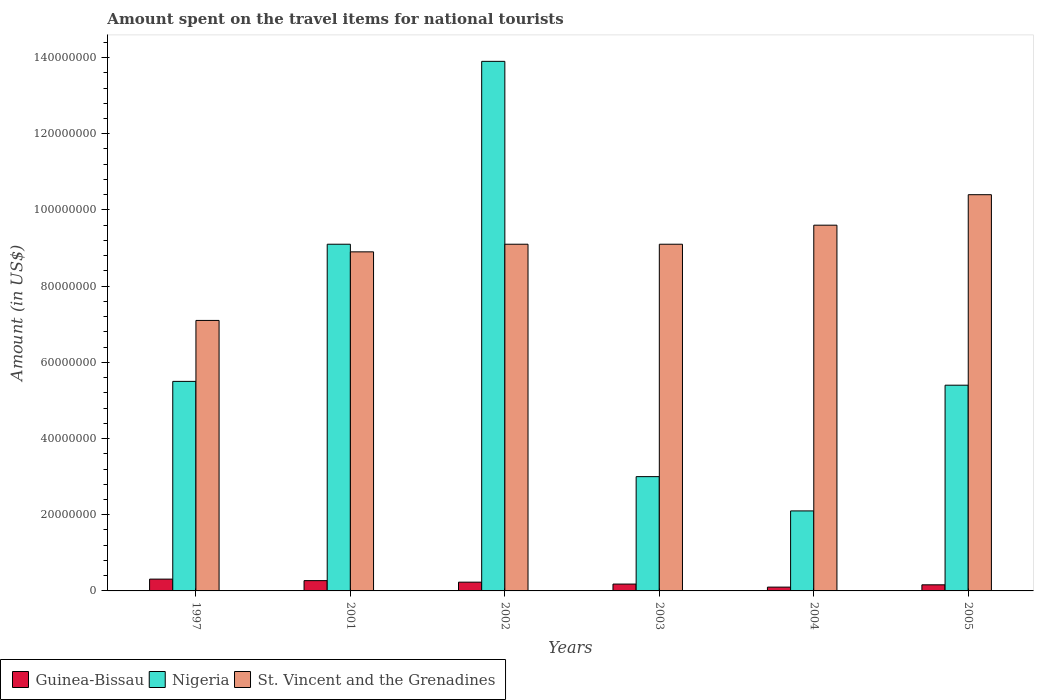How many groups of bars are there?
Provide a short and direct response. 6. Are the number of bars on each tick of the X-axis equal?
Your answer should be very brief. Yes. In how many cases, is the number of bars for a given year not equal to the number of legend labels?
Give a very brief answer. 0. What is the amount spent on the travel items for national tourists in St. Vincent and the Grenadines in 1997?
Provide a succinct answer. 7.10e+07. Across all years, what is the maximum amount spent on the travel items for national tourists in St. Vincent and the Grenadines?
Make the answer very short. 1.04e+08. Across all years, what is the minimum amount spent on the travel items for national tourists in St. Vincent and the Grenadines?
Give a very brief answer. 7.10e+07. In which year was the amount spent on the travel items for national tourists in Guinea-Bissau minimum?
Your answer should be compact. 2004. What is the total amount spent on the travel items for national tourists in Guinea-Bissau in the graph?
Give a very brief answer. 1.25e+07. What is the difference between the amount spent on the travel items for national tourists in Guinea-Bissau in 1997 and that in 2003?
Offer a terse response. 1.30e+06. What is the difference between the amount spent on the travel items for national tourists in Guinea-Bissau in 2003 and the amount spent on the travel items for national tourists in St. Vincent and the Grenadines in 2001?
Ensure brevity in your answer.  -8.72e+07. What is the average amount spent on the travel items for national tourists in Guinea-Bissau per year?
Keep it short and to the point. 2.08e+06. In the year 2005, what is the difference between the amount spent on the travel items for national tourists in St. Vincent and the Grenadines and amount spent on the travel items for national tourists in Guinea-Bissau?
Your answer should be compact. 1.02e+08. What is the ratio of the amount spent on the travel items for national tourists in Nigeria in 1997 to that in 2002?
Keep it short and to the point. 0.4. What is the difference between the highest and the second highest amount spent on the travel items for national tourists in Guinea-Bissau?
Make the answer very short. 4.00e+05. What is the difference between the highest and the lowest amount spent on the travel items for national tourists in St. Vincent and the Grenadines?
Provide a succinct answer. 3.30e+07. What does the 3rd bar from the left in 2001 represents?
Make the answer very short. St. Vincent and the Grenadines. What does the 3rd bar from the right in 2002 represents?
Make the answer very short. Guinea-Bissau. How many years are there in the graph?
Keep it short and to the point. 6. What is the difference between two consecutive major ticks on the Y-axis?
Your response must be concise. 2.00e+07. Does the graph contain any zero values?
Ensure brevity in your answer.  No. Where does the legend appear in the graph?
Give a very brief answer. Bottom left. How are the legend labels stacked?
Keep it short and to the point. Horizontal. What is the title of the graph?
Your answer should be very brief. Amount spent on the travel items for national tourists. What is the Amount (in US$) of Guinea-Bissau in 1997?
Your answer should be compact. 3.10e+06. What is the Amount (in US$) of Nigeria in 1997?
Make the answer very short. 5.50e+07. What is the Amount (in US$) of St. Vincent and the Grenadines in 1997?
Offer a terse response. 7.10e+07. What is the Amount (in US$) of Guinea-Bissau in 2001?
Provide a succinct answer. 2.70e+06. What is the Amount (in US$) in Nigeria in 2001?
Ensure brevity in your answer.  9.10e+07. What is the Amount (in US$) in St. Vincent and the Grenadines in 2001?
Your answer should be compact. 8.90e+07. What is the Amount (in US$) in Guinea-Bissau in 2002?
Offer a very short reply. 2.30e+06. What is the Amount (in US$) in Nigeria in 2002?
Give a very brief answer. 1.39e+08. What is the Amount (in US$) of St. Vincent and the Grenadines in 2002?
Ensure brevity in your answer.  9.10e+07. What is the Amount (in US$) of Guinea-Bissau in 2003?
Offer a very short reply. 1.80e+06. What is the Amount (in US$) of Nigeria in 2003?
Offer a very short reply. 3.00e+07. What is the Amount (in US$) in St. Vincent and the Grenadines in 2003?
Provide a short and direct response. 9.10e+07. What is the Amount (in US$) in Guinea-Bissau in 2004?
Your response must be concise. 1.00e+06. What is the Amount (in US$) of Nigeria in 2004?
Your answer should be very brief. 2.10e+07. What is the Amount (in US$) in St. Vincent and the Grenadines in 2004?
Keep it short and to the point. 9.60e+07. What is the Amount (in US$) of Guinea-Bissau in 2005?
Ensure brevity in your answer.  1.60e+06. What is the Amount (in US$) in Nigeria in 2005?
Make the answer very short. 5.40e+07. What is the Amount (in US$) in St. Vincent and the Grenadines in 2005?
Offer a terse response. 1.04e+08. Across all years, what is the maximum Amount (in US$) of Guinea-Bissau?
Keep it short and to the point. 3.10e+06. Across all years, what is the maximum Amount (in US$) in Nigeria?
Offer a terse response. 1.39e+08. Across all years, what is the maximum Amount (in US$) of St. Vincent and the Grenadines?
Offer a terse response. 1.04e+08. Across all years, what is the minimum Amount (in US$) in Nigeria?
Your response must be concise. 2.10e+07. Across all years, what is the minimum Amount (in US$) in St. Vincent and the Grenadines?
Make the answer very short. 7.10e+07. What is the total Amount (in US$) of Guinea-Bissau in the graph?
Your response must be concise. 1.25e+07. What is the total Amount (in US$) of Nigeria in the graph?
Your answer should be very brief. 3.90e+08. What is the total Amount (in US$) in St. Vincent and the Grenadines in the graph?
Give a very brief answer. 5.42e+08. What is the difference between the Amount (in US$) of Nigeria in 1997 and that in 2001?
Your answer should be very brief. -3.60e+07. What is the difference between the Amount (in US$) of St. Vincent and the Grenadines in 1997 and that in 2001?
Give a very brief answer. -1.80e+07. What is the difference between the Amount (in US$) of Nigeria in 1997 and that in 2002?
Provide a short and direct response. -8.40e+07. What is the difference between the Amount (in US$) in St. Vincent and the Grenadines in 1997 and that in 2002?
Your answer should be compact. -2.00e+07. What is the difference between the Amount (in US$) in Guinea-Bissau in 1997 and that in 2003?
Provide a succinct answer. 1.30e+06. What is the difference between the Amount (in US$) in Nigeria in 1997 and that in 2003?
Give a very brief answer. 2.50e+07. What is the difference between the Amount (in US$) of St. Vincent and the Grenadines in 1997 and that in 2003?
Your answer should be compact. -2.00e+07. What is the difference between the Amount (in US$) in Guinea-Bissau in 1997 and that in 2004?
Your answer should be very brief. 2.10e+06. What is the difference between the Amount (in US$) in Nigeria in 1997 and that in 2004?
Offer a very short reply. 3.40e+07. What is the difference between the Amount (in US$) of St. Vincent and the Grenadines in 1997 and that in 2004?
Offer a terse response. -2.50e+07. What is the difference between the Amount (in US$) in Guinea-Bissau in 1997 and that in 2005?
Offer a terse response. 1.50e+06. What is the difference between the Amount (in US$) of Nigeria in 1997 and that in 2005?
Your response must be concise. 1.00e+06. What is the difference between the Amount (in US$) of St. Vincent and the Grenadines in 1997 and that in 2005?
Your response must be concise. -3.30e+07. What is the difference between the Amount (in US$) in Nigeria in 2001 and that in 2002?
Make the answer very short. -4.80e+07. What is the difference between the Amount (in US$) in St. Vincent and the Grenadines in 2001 and that in 2002?
Your answer should be very brief. -2.00e+06. What is the difference between the Amount (in US$) of Guinea-Bissau in 2001 and that in 2003?
Your answer should be very brief. 9.00e+05. What is the difference between the Amount (in US$) of Nigeria in 2001 and that in 2003?
Your answer should be compact. 6.10e+07. What is the difference between the Amount (in US$) in St. Vincent and the Grenadines in 2001 and that in 2003?
Give a very brief answer. -2.00e+06. What is the difference between the Amount (in US$) of Guinea-Bissau in 2001 and that in 2004?
Give a very brief answer. 1.70e+06. What is the difference between the Amount (in US$) of Nigeria in 2001 and that in 2004?
Your answer should be compact. 7.00e+07. What is the difference between the Amount (in US$) in St. Vincent and the Grenadines in 2001 and that in 2004?
Your answer should be very brief. -7.00e+06. What is the difference between the Amount (in US$) in Guinea-Bissau in 2001 and that in 2005?
Your response must be concise. 1.10e+06. What is the difference between the Amount (in US$) of Nigeria in 2001 and that in 2005?
Provide a succinct answer. 3.70e+07. What is the difference between the Amount (in US$) in St. Vincent and the Grenadines in 2001 and that in 2005?
Your answer should be very brief. -1.50e+07. What is the difference between the Amount (in US$) of Nigeria in 2002 and that in 2003?
Keep it short and to the point. 1.09e+08. What is the difference between the Amount (in US$) in St. Vincent and the Grenadines in 2002 and that in 2003?
Ensure brevity in your answer.  0. What is the difference between the Amount (in US$) of Guinea-Bissau in 2002 and that in 2004?
Give a very brief answer. 1.30e+06. What is the difference between the Amount (in US$) of Nigeria in 2002 and that in 2004?
Your response must be concise. 1.18e+08. What is the difference between the Amount (in US$) in St. Vincent and the Grenadines in 2002 and that in 2004?
Give a very brief answer. -5.00e+06. What is the difference between the Amount (in US$) in Nigeria in 2002 and that in 2005?
Your response must be concise. 8.50e+07. What is the difference between the Amount (in US$) in St. Vincent and the Grenadines in 2002 and that in 2005?
Offer a terse response. -1.30e+07. What is the difference between the Amount (in US$) in Nigeria in 2003 and that in 2004?
Make the answer very short. 9.00e+06. What is the difference between the Amount (in US$) in St. Vincent and the Grenadines in 2003 and that in 2004?
Provide a succinct answer. -5.00e+06. What is the difference between the Amount (in US$) in Guinea-Bissau in 2003 and that in 2005?
Make the answer very short. 2.00e+05. What is the difference between the Amount (in US$) in Nigeria in 2003 and that in 2005?
Keep it short and to the point. -2.40e+07. What is the difference between the Amount (in US$) in St. Vincent and the Grenadines in 2003 and that in 2005?
Provide a short and direct response. -1.30e+07. What is the difference between the Amount (in US$) of Guinea-Bissau in 2004 and that in 2005?
Your answer should be compact. -6.00e+05. What is the difference between the Amount (in US$) of Nigeria in 2004 and that in 2005?
Your answer should be very brief. -3.30e+07. What is the difference between the Amount (in US$) of St. Vincent and the Grenadines in 2004 and that in 2005?
Your answer should be very brief. -8.00e+06. What is the difference between the Amount (in US$) of Guinea-Bissau in 1997 and the Amount (in US$) of Nigeria in 2001?
Give a very brief answer. -8.79e+07. What is the difference between the Amount (in US$) of Guinea-Bissau in 1997 and the Amount (in US$) of St. Vincent and the Grenadines in 2001?
Your answer should be compact. -8.59e+07. What is the difference between the Amount (in US$) of Nigeria in 1997 and the Amount (in US$) of St. Vincent and the Grenadines in 2001?
Your response must be concise. -3.40e+07. What is the difference between the Amount (in US$) in Guinea-Bissau in 1997 and the Amount (in US$) in Nigeria in 2002?
Make the answer very short. -1.36e+08. What is the difference between the Amount (in US$) in Guinea-Bissau in 1997 and the Amount (in US$) in St. Vincent and the Grenadines in 2002?
Your answer should be compact. -8.79e+07. What is the difference between the Amount (in US$) of Nigeria in 1997 and the Amount (in US$) of St. Vincent and the Grenadines in 2002?
Provide a succinct answer. -3.60e+07. What is the difference between the Amount (in US$) of Guinea-Bissau in 1997 and the Amount (in US$) of Nigeria in 2003?
Give a very brief answer. -2.69e+07. What is the difference between the Amount (in US$) in Guinea-Bissau in 1997 and the Amount (in US$) in St. Vincent and the Grenadines in 2003?
Your response must be concise. -8.79e+07. What is the difference between the Amount (in US$) in Nigeria in 1997 and the Amount (in US$) in St. Vincent and the Grenadines in 2003?
Offer a terse response. -3.60e+07. What is the difference between the Amount (in US$) in Guinea-Bissau in 1997 and the Amount (in US$) in Nigeria in 2004?
Offer a terse response. -1.79e+07. What is the difference between the Amount (in US$) of Guinea-Bissau in 1997 and the Amount (in US$) of St. Vincent and the Grenadines in 2004?
Offer a very short reply. -9.29e+07. What is the difference between the Amount (in US$) in Nigeria in 1997 and the Amount (in US$) in St. Vincent and the Grenadines in 2004?
Your response must be concise. -4.10e+07. What is the difference between the Amount (in US$) in Guinea-Bissau in 1997 and the Amount (in US$) in Nigeria in 2005?
Offer a terse response. -5.09e+07. What is the difference between the Amount (in US$) in Guinea-Bissau in 1997 and the Amount (in US$) in St. Vincent and the Grenadines in 2005?
Offer a very short reply. -1.01e+08. What is the difference between the Amount (in US$) in Nigeria in 1997 and the Amount (in US$) in St. Vincent and the Grenadines in 2005?
Your answer should be compact. -4.90e+07. What is the difference between the Amount (in US$) in Guinea-Bissau in 2001 and the Amount (in US$) in Nigeria in 2002?
Make the answer very short. -1.36e+08. What is the difference between the Amount (in US$) in Guinea-Bissau in 2001 and the Amount (in US$) in St. Vincent and the Grenadines in 2002?
Your answer should be compact. -8.83e+07. What is the difference between the Amount (in US$) of Guinea-Bissau in 2001 and the Amount (in US$) of Nigeria in 2003?
Your answer should be compact. -2.73e+07. What is the difference between the Amount (in US$) of Guinea-Bissau in 2001 and the Amount (in US$) of St. Vincent and the Grenadines in 2003?
Your answer should be very brief. -8.83e+07. What is the difference between the Amount (in US$) of Guinea-Bissau in 2001 and the Amount (in US$) of Nigeria in 2004?
Ensure brevity in your answer.  -1.83e+07. What is the difference between the Amount (in US$) of Guinea-Bissau in 2001 and the Amount (in US$) of St. Vincent and the Grenadines in 2004?
Your answer should be very brief. -9.33e+07. What is the difference between the Amount (in US$) of Nigeria in 2001 and the Amount (in US$) of St. Vincent and the Grenadines in 2004?
Provide a succinct answer. -5.00e+06. What is the difference between the Amount (in US$) of Guinea-Bissau in 2001 and the Amount (in US$) of Nigeria in 2005?
Offer a terse response. -5.13e+07. What is the difference between the Amount (in US$) in Guinea-Bissau in 2001 and the Amount (in US$) in St. Vincent and the Grenadines in 2005?
Offer a terse response. -1.01e+08. What is the difference between the Amount (in US$) of Nigeria in 2001 and the Amount (in US$) of St. Vincent and the Grenadines in 2005?
Offer a very short reply. -1.30e+07. What is the difference between the Amount (in US$) in Guinea-Bissau in 2002 and the Amount (in US$) in Nigeria in 2003?
Your answer should be very brief. -2.77e+07. What is the difference between the Amount (in US$) of Guinea-Bissau in 2002 and the Amount (in US$) of St. Vincent and the Grenadines in 2003?
Your answer should be compact. -8.87e+07. What is the difference between the Amount (in US$) in Nigeria in 2002 and the Amount (in US$) in St. Vincent and the Grenadines in 2003?
Your response must be concise. 4.80e+07. What is the difference between the Amount (in US$) in Guinea-Bissau in 2002 and the Amount (in US$) in Nigeria in 2004?
Offer a very short reply. -1.87e+07. What is the difference between the Amount (in US$) of Guinea-Bissau in 2002 and the Amount (in US$) of St. Vincent and the Grenadines in 2004?
Offer a very short reply. -9.37e+07. What is the difference between the Amount (in US$) of Nigeria in 2002 and the Amount (in US$) of St. Vincent and the Grenadines in 2004?
Provide a short and direct response. 4.30e+07. What is the difference between the Amount (in US$) of Guinea-Bissau in 2002 and the Amount (in US$) of Nigeria in 2005?
Your answer should be compact. -5.17e+07. What is the difference between the Amount (in US$) of Guinea-Bissau in 2002 and the Amount (in US$) of St. Vincent and the Grenadines in 2005?
Provide a succinct answer. -1.02e+08. What is the difference between the Amount (in US$) of Nigeria in 2002 and the Amount (in US$) of St. Vincent and the Grenadines in 2005?
Provide a short and direct response. 3.50e+07. What is the difference between the Amount (in US$) of Guinea-Bissau in 2003 and the Amount (in US$) of Nigeria in 2004?
Your answer should be very brief. -1.92e+07. What is the difference between the Amount (in US$) of Guinea-Bissau in 2003 and the Amount (in US$) of St. Vincent and the Grenadines in 2004?
Provide a short and direct response. -9.42e+07. What is the difference between the Amount (in US$) of Nigeria in 2003 and the Amount (in US$) of St. Vincent and the Grenadines in 2004?
Give a very brief answer. -6.60e+07. What is the difference between the Amount (in US$) in Guinea-Bissau in 2003 and the Amount (in US$) in Nigeria in 2005?
Make the answer very short. -5.22e+07. What is the difference between the Amount (in US$) of Guinea-Bissau in 2003 and the Amount (in US$) of St. Vincent and the Grenadines in 2005?
Offer a terse response. -1.02e+08. What is the difference between the Amount (in US$) in Nigeria in 2003 and the Amount (in US$) in St. Vincent and the Grenadines in 2005?
Your answer should be compact. -7.40e+07. What is the difference between the Amount (in US$) of Guinea-Bissau in 2004 and the Amount (in US$) of Nigeria in 2005?
Your response must be concise. -5.30e+07. What is the difference between the Amount (in US$) of Guinea-Bissau in 2004 and the Amount (in US$) of St. Vincent and the Grenadines in 2005?
Ensure brevity in your answer.  -1.03e+08. What is the difference between the Amount (in US$) in Nigeria in 2004 and the Amount (in US$) in St. Vincent and the Grenadines in 2005?
Your answer should be compact. -8.30e+07. What is the average Amount (in US$) of Guinea-Bissau per year?
Your answer should be very brief. 2.08e+06. What is the average Amount (in US$) in Nigeria per year?
Provide a short and direct response. 6.50e+07. What is the average Amount (in US$) in St. Vincent and the Grenadines per year?
Give a very brief answer. 9.03e+07. In the year 1997, what is the difference between the Amount (in US$) in Guinea-Bissau and Amount (in US$) in Nigeria?
Your answer should be compact. -5.19e+07. In the year 1997, what is the difference between the Amount (in US$) of Guinea-Bissau and Amount (in US$) of St. Vincent and the Grenadines?
Offer a terse response. -6.79e+07. In the year 1997, what is the difference between the Amount (in US$) in Nigeria and Amount (in US$) in St. Vincent and the Grenadines?
Provide a succinct answer. -1.60e+07. In the year 2001, what is the difference between the Amount (in US$) in Guinea-Bissau and Amount (in US$) in Nigeria?
Offer a very short reply. -8.83e+07. In the year 2001, what is the difference between the Amount (in US$) of Guinea-Bissau and Amount (in US$) of St. Vincent and the Grenadines?
Keep it short and to the point. -8.63e+07. In the year 2002, what is the difference between the Amount (in US$) in Guinea-Bissau and Amount (in US$) in Nigeria?
Keep it short and to the point. -1.37e+08. In the year 2002, what is the difference between the Amount (in US$) of Guinea-Bissau and Amount (in US$) of St. Vincent and the Grenadines?
Your answer should be compact. -8.87e+07. In the year 2002, what is the difference between the Amount (in US$) in Nigeria and Amount (in US$) in St. Vincent and the Grenadines?
Make the answer very short. 4.80e+07. In the year 2003, what is the difference between the Amount (in US$) in Guinea-Bissau and Amount (in US$) in Nigeria?
Give a very brief answer. -2.82e+07. In the year 2003, what is the difference between the Amount (in US$) of Guinea-Bissau and Amount (in US$) of St. Vincent and the Grenadines?
Your answer should be compact. -8.92e+07. In the year 2003, what is the difference between the Amount (in US$) of Nigeria and Amount (in US$) of St. Vincent and the Grenadines?
Provide a succinct answer. -6.10e+07. In the year 2004, what is the difference between the Amount (in US$) in Guinea-Bissau and Amount (in US$) in Nigeria?
Ensure brevity in your answer.  -2.00e+07. In the year 2004, what is the difference between the Amount (in US$) of Guinea-Bissau and Amount (in US$) of St. Vincent and the Grenadines?
Keep it short and to the point. -9.50e+07. In the year 2004, what is the difference between the Amount (in US$) of Nigeria and Amount (in US$) of St. Vincent and the Grenadines?
Offer a very short reply. -7.50e+07. In the year 2005, what is the difference between the Amount (in US$) of Guinea-Bissau and Amount (in US$) of Nigeria?
Provide a short and direct response. -5.24e+07. In the year 2005, what is the difference between the Amount (in US$) of Guinea-Bissau and Amount (in US$) of St. Vincent and the Grenadines?
Your answer should be compact. -1.02e+08. In the year 2005, what is the difference between the Amount (in US$) in Nigeria and Amount (in US$) in St. Vincent and the Grenadines?
Offer a very short reply. -5.00e+07. What is the ratio of the Amount (in US$) of Guinea-Bissau in 1997 to that in 2001?
Your answer should be compact. 1.15. What is the ratio of the Amount (in US$) in Nigeria in 1997 to that in 2001?
Give a very brief answer. 0.6. What is the ratio of the Amount (in US$) of St. Vincent and the Grenadines in 1997 to that in 2001?
Give a very brief answer. 0.8. What is the ratio of the Amount (in US$) in Guinea-Bissau in 1997 to that in 2002?
Offer a very short reply. 1.35. What is the ratio of the Amount (in US$) in Nigeria in 1997 to that in 2002?
Give a very brief answer. 0.4. What is the ratio of the Amount (in US$) of St. Vincent and the Grenadines in 1997 to that in 2002?
Provide a short and direct response. 0.78. What is the ratio of the Amount (in US$) of Guinea-Bissau in 1997 to that in 2003?
Your response must be concise. 1.72. What is the ratio of the Amount (in US$) of Nigeria in 1997 to that in 2003?
Keep it short and to the point. 1.83. What is the ratio of the Amount (in US$) of St. Vincent and the Grenadines in 1997 to that in 2003?
Ensure brevity in your answer.  0.78. What is the ratio of the Amount (in US$) in Guinea-Bissau in 1997 to that in 2004?
Give a very brief answer. 3.1. What is the ratio of the Amount (in US$) of Nigeria in 1997 to that in 2004?
Your response must be concise. 2.62. What is the ratio of the Amount (in US$) in St. Vincent and the Grenadines in 1997 to that in 2004?
Offer a very short reply. 0.74. What is the ratio of the Amount (in US$) of Guinea-Bissau in 1997 to that in 2005?
Keep it short and to the point. 1.94. What is the ratio of the Amount (in US$) of Nigeria in 1997 to that in 2005?
Provide a short and direct response. 1.02. What is the ratio of the Amount (in US$) of St. Vincent and the Grenadines in 1997 to that in 2005?
Offer a terse response. 0.68. What is the ratio of the Amount (in US$) in Guinea-Bissau in 2001 to that in 2002?
Your response must be concise. 1.17. What is the ratio of the Amount (in US$) in Nigeria in 2001 to that in 2002?
Make the answer very short. 0.65. What is the ratio of the Amount (in US$) in St. Vincent and the Grenadines in 2001 to that in 2002?
Your answer should be compact. 0.98. What is the ratio of the Amount (in US$) in Nigeria in 2001 to that in 2003?
Offer a terse response. 3.03. What is the ratio of the Amount (in US$) in Guinea-Bissau in 2001 to that in 2004?
Give a very brief answer. 2.7. What is the ratio of the Amount (in US$) of Nigeria in 2001 to that in 2004?
Your response must be concise. 4.33. What is the ratio of the Amount (in US$) in St. Vincent and the Grenadines in 2001 to that in 2004?
Give a very brief answer. 0.93. What is the ratio of the Amount (in US$) of Guinea-Bissau in 2001 to that in 2005?
Provide a short and direct response. 1.69. What is the ratio of the Amount (in US$) in Nigeria in 2001 to that in 2005?
Give a very brief answer. 1.69. What is the ratio of the Amount (in US$) of St. Vincent and the Grenadines in 2001 to that in 2005?
Give a very brief answer. 0.86. What is the ratio of the Amount (in US$) of Guinea-Bissau in 2002 to that in 2003?
Ensure brevity in your answer.  1.28. What is the ratio of the Amount (in US$) in Nigeria in 2002 to that in 2003?
Provide a succinct answer. 4.63. What is the ratio of the Amount (in US$) of St. Vincent and the Grenadines in 2002 to that in 2003?
Your answer should be compact. 1. What is the ratio of the Amount (in US$) of Nigeria in 2002 to that in 2004?
Your answer should be very brief. 6.62. What is the ratio of the Amount (in US$) of St. Vincent and the Grenadines in 2002 to that in 2004?
Make the answer very short. 0.95. What is the ratio of the Amount (in US$) of Guinea-Bissau in 2002 to that in 2005?
Make the answer very short. 1.44. What is the ratio of the Amount (in US$) in Nigeria in 2002 to that in 2005?
Provide a succinct answer. 2.57. What is the ratio of the Amount (in US$) of St. Vincent and the Grenadines in 2002 to that in 2005?
Offer a very short reply. 0.88. What is the ratio of the Amount (in US$) in Guinea-Bissau in 2003 to that in 2004?
Give a very brief answer. 1.8. What is the ratio of the Amount (in US$) of Nigeria in 2003 to that in 2004?
Give a very brief answer. 1.43. What is the ratio of the Amount (in US$) of St. Vincent and the Grenadines in 2003 to that in 2004?
Give a very brief answer. 0.95. What is the ratio of the Amount (in US$) of Nigeria in 2003 to that in 2005?
Provide a short and direct response. 0.56. What is the ratio of the Amount (in US$) in St. Vincent and the Grenadines in 2003 to that in 2005?
Offer a terse response. 0.88. What is the ratio of the Amount (in US$) of Guinea-Bissau in 2004 to that in 2005?
Make the answer very short. 0.62. What is the ratio of the Amount (in US$) in Nigeria in 2004 to that in 2005?
Give a very brief answer. 0.39. What is the ratio of the Amount (in US$) in St. Vincent and the Grenadines in 2004 to that in 2005?
Provide a succinct answer. 0.92. What is the difference between the highest and the second highest Amount (in US$) in Guinea-Bissau?
Give a very brief answer. 4.00e+05. What is the difference between the highest and the second highest Amount (in US$) of Nigeria?
Provide a short and direct response. 4.80e+07. What is the difference between the highest and the second highest Amount (in US$) in St. Vincent and the Grenadines?
Give a very brief answer. 8.00e+06. What is the difference between the highest and the lowest Amount (in US$) of Guinea-Bissau?
Offer a terse response. 2.10e+06. What is the difference between the highest and the lowest Amount (in US$) in Nigeria?
Ensure brevity in your answer.  1.18e+08. What is the difference between the highest and the lowest Amount (in US$) of St. Vincent and the Grenadines?
Ensure brevity in your answer.  3.30e+07. 